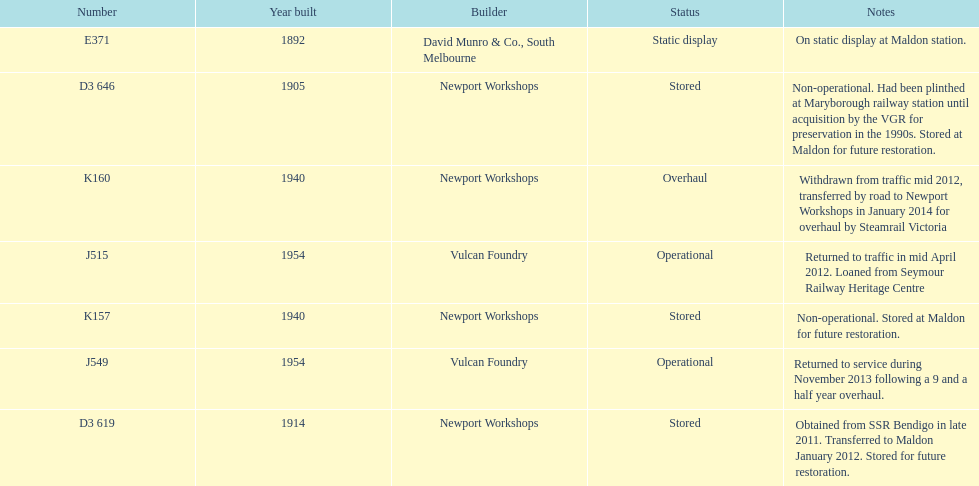How many of the locomotives were built before 1940? 3. 